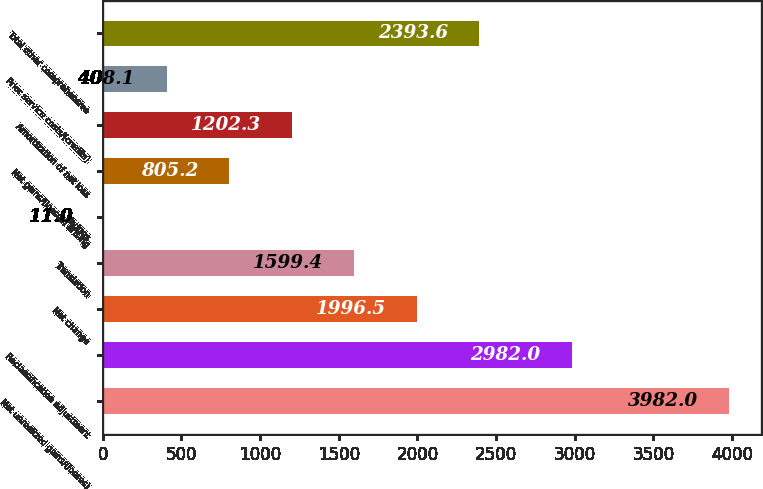Convert chart to OTSL. <chart><loc_0><loc_0><loc_500><loc_500><bar_chart><fcel>Net unrealized gains/(losses)<fcel>Reclassification adjustment<fcel>Net change<fcel>Translation<fcel>Hedges<fcel>Net gains/(losses) arising<fcel>Amortization of net loss<fcel>Prior service costs/(credits)<fcel>Total other comprehensive<nl><fcel>3982<fcel>2982<fcel>1996.5<fcel>1599.4<fcel>11<fcel>805.2<fcel>1202.3<fcel>408.1<fcel>2393.6<nl></chart> 